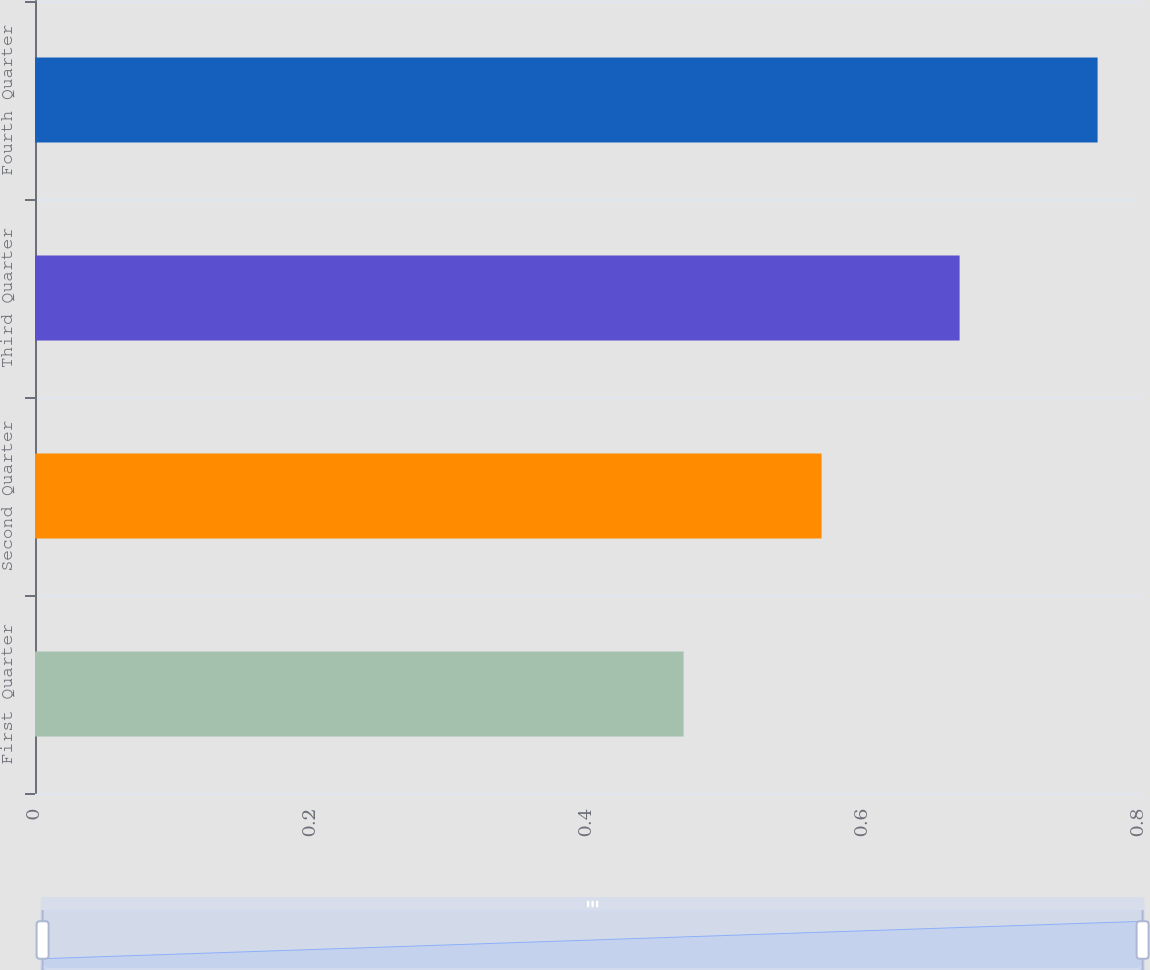<chart> <loc_0><loc_0><loc_500><loc_500><bar_chart><fcel>First Quarter<fcel>Second Quarter<fcel>Third Quarter<fcel>Fourth Quarter<nl><fcel>0.47<fcel>0.57<fcel>0.67<fcel>0.77<nl></chart> 